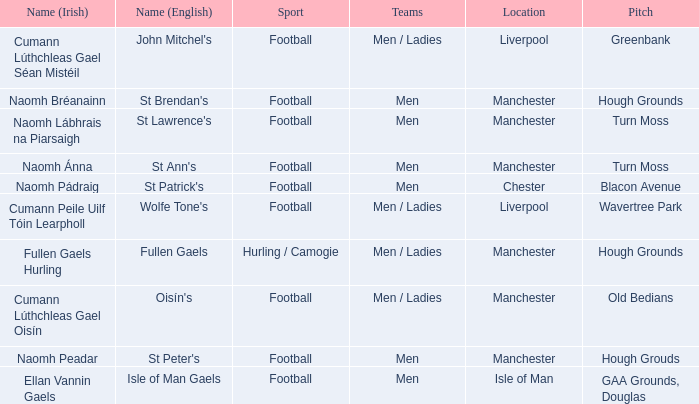What is the Location of the Old Bedians Pitch? Manchester. 